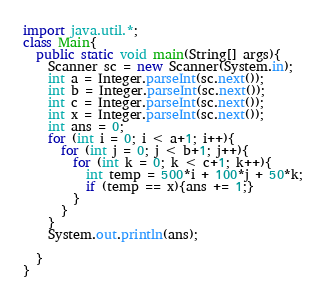<code> <loc_0><loc_0><loc_500><loc_500><_Java_>import java.util.*;
class Main{
  public static void main(String[] args){
    Scanner sc = new Scanner(System.in);
    int a = Integer.parseInt(sc.next());
    int b = Integer.parseInt(sc.next());
    int c = Integer.parseInt(sc.next());
    int x = Integer.parseInt(sc.next());
    int ans = 0;
    for (int i = 0; i < a+1; i++){
      for (int j = 0; j < b+1; j++){
        for (int k = 0; k < c+1; k++){
          int temp = 500*i + 100*j + 50*k;
          if (temp == x){ans += 1;}
        }
      }
    }
    System.out.println(ans);
    
  }
}
</code> 